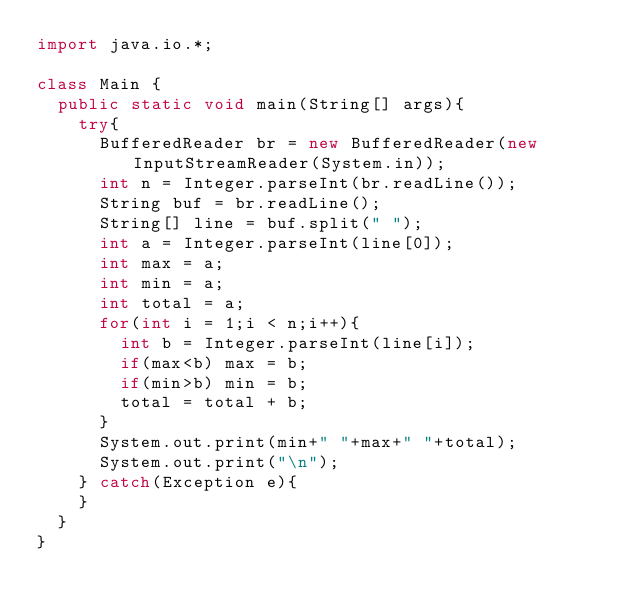Convert code to text. <code><loc_0><loc_0><loc_500><loc_500><_Java_>import java.io.*;

class Main {
	public static void main(String[] args){
		try{
			BufferedReader br = new BufferedReader(new InputStreamReader(System.in));
			int n = Integer.parseInt(br.readLine());
			String buf = br.readLine();
			String[] line = buf.split(" ");
			int a = Integer.parseInt(line[0]);
			int max = a;
			int min = a;
			int total = a;
			for(int i = 1;i < n;i++){
				int b = Integer.parseInt(line[i]);
				if(max<b) max = b;
				if(min>b) min = b;
				total = total + b;
			}
			System.out.print(min+" "+max+" "+total);
			System.out.print("\n");
		} catch(Exception e){
		}
	}
}</code> 